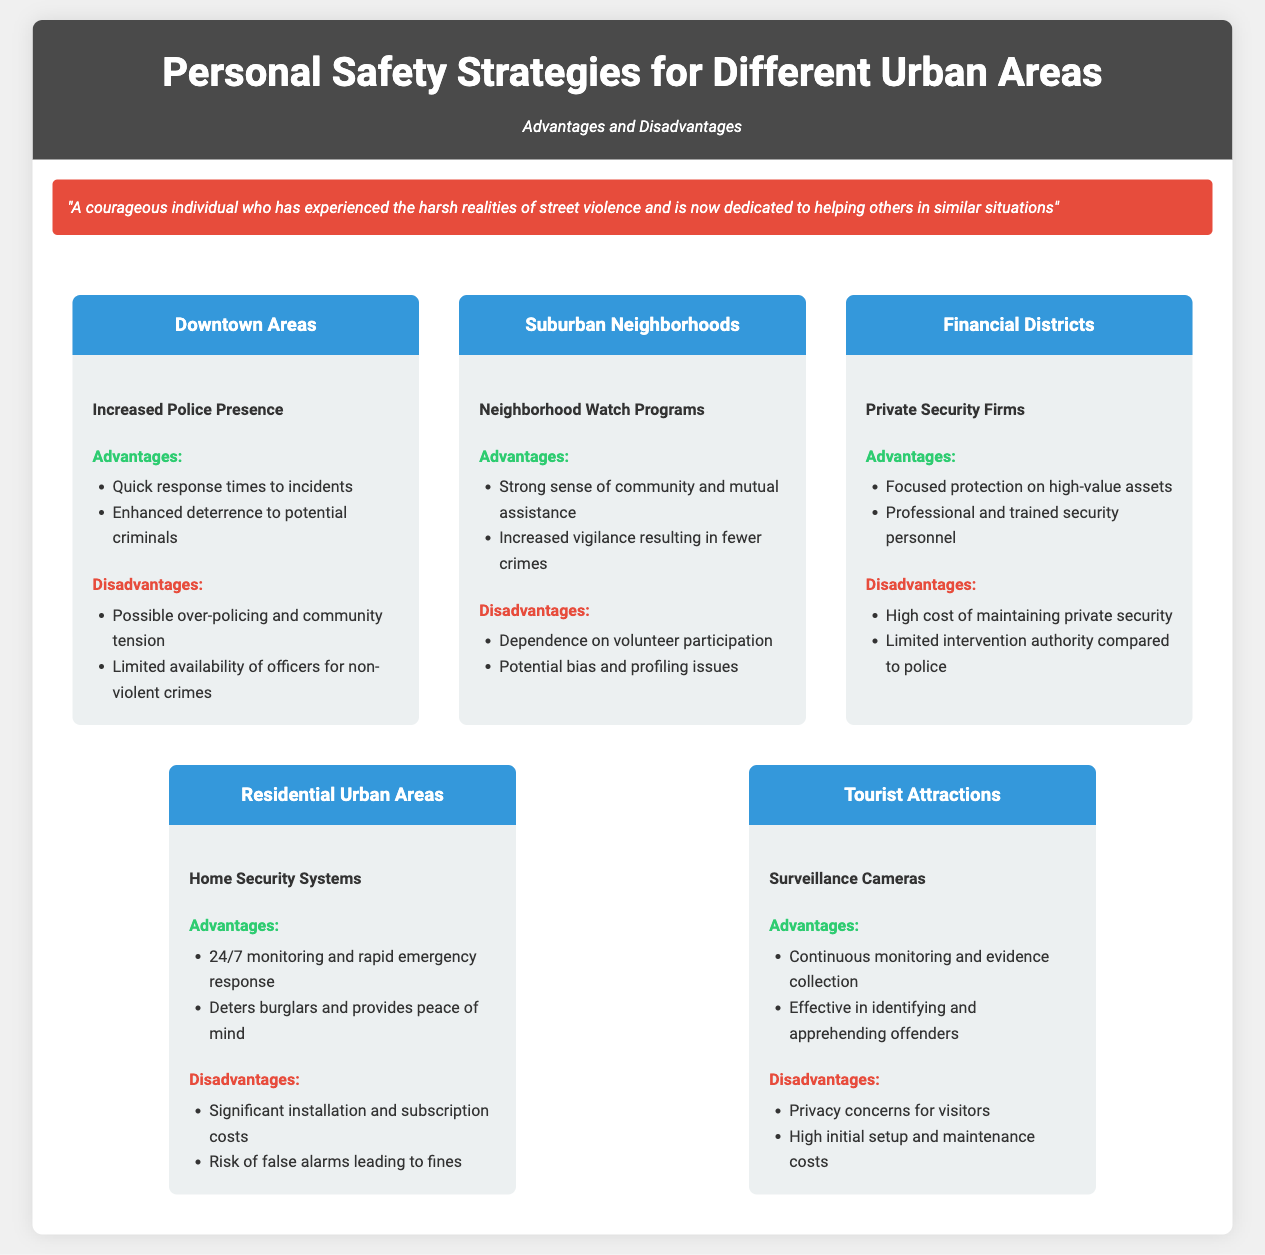what is the primary personal safety strategy mentioned for Downtown Areas? The primary strategy is Increased Police Presence, which is mentioned in the section about Downtown Areas.
Answer: Increased Police Presence what is one advantage of Neighborhood Watch Programs? One advantage listed for Neighborhood Watch Programs is increased vigilance, which leads to fewer crimes.
Answer: Increased vigilance resulting in fewer crimes how many strategies are discussed in the document? The document outlines a total of five strategies, each associated with different urban areas.
Answer: Five what is a disadvantage of using Private Security Firms? One of the disadvantages highlighted is the high cost of maintaining private security.
Answer: High cost of maintaining private security what type of monitoring is provided by Home Security Systems? Home Security Systems provide 24/7 monitoring and rapid emergency response, as stated in the Residential Urban Areas section.
Answer: 24/7 monitoring and rapid emergency response which personal safety strategy includes the use of Surveillance Cameras? Surveillance Cameras are specifically mentioned under the strategy for Tourist Attractions.
Answer: Surveillance Cameras 